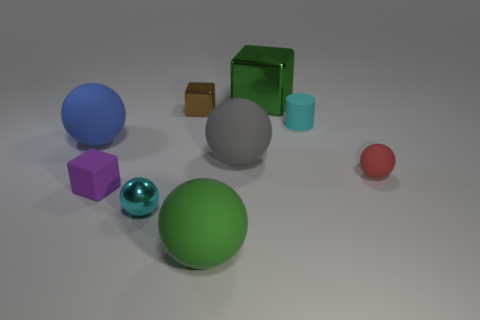Subtract all tiny metallic balls. How many balls are left? 4 Subtract all blue balls. How many balls are left? 4 Subtract all yellow spheres. Subtract all green cylinders. How many spheres are left? 5 Add 3 green metallic objects. How many green metallic objects exist? 4 Subtract 1 red spheres. How many objects are left? 8 Subtract all blocks. How many objects are left? 6 Subtract all small cyan metallic objects. Subtract all purple objects. How many objects are left? 7 Add 5 brown blocks. How many brown blocks are left? 6 